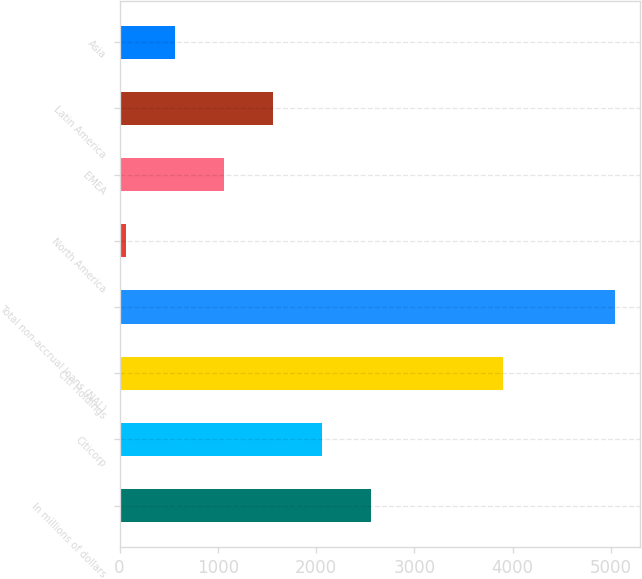Convert chart. <chart><loc_0><loc_0><loc_500><loc_500><bar_chart><fcel>In millions of dollars<fcel>Citicorp<fcel>Citi Holdings<fcel>Total non-accrual loans (NAL)<fcel>North America<fcel>EMEA<fcel>Latin America<fcel>Asia<nl><fcel>2557.5<fcel>2059.6<fcel>3906<fcel>5047<fcel>68<fcel>1063.8<fcel>1561.7<fcel>565.9<nl></chart> 